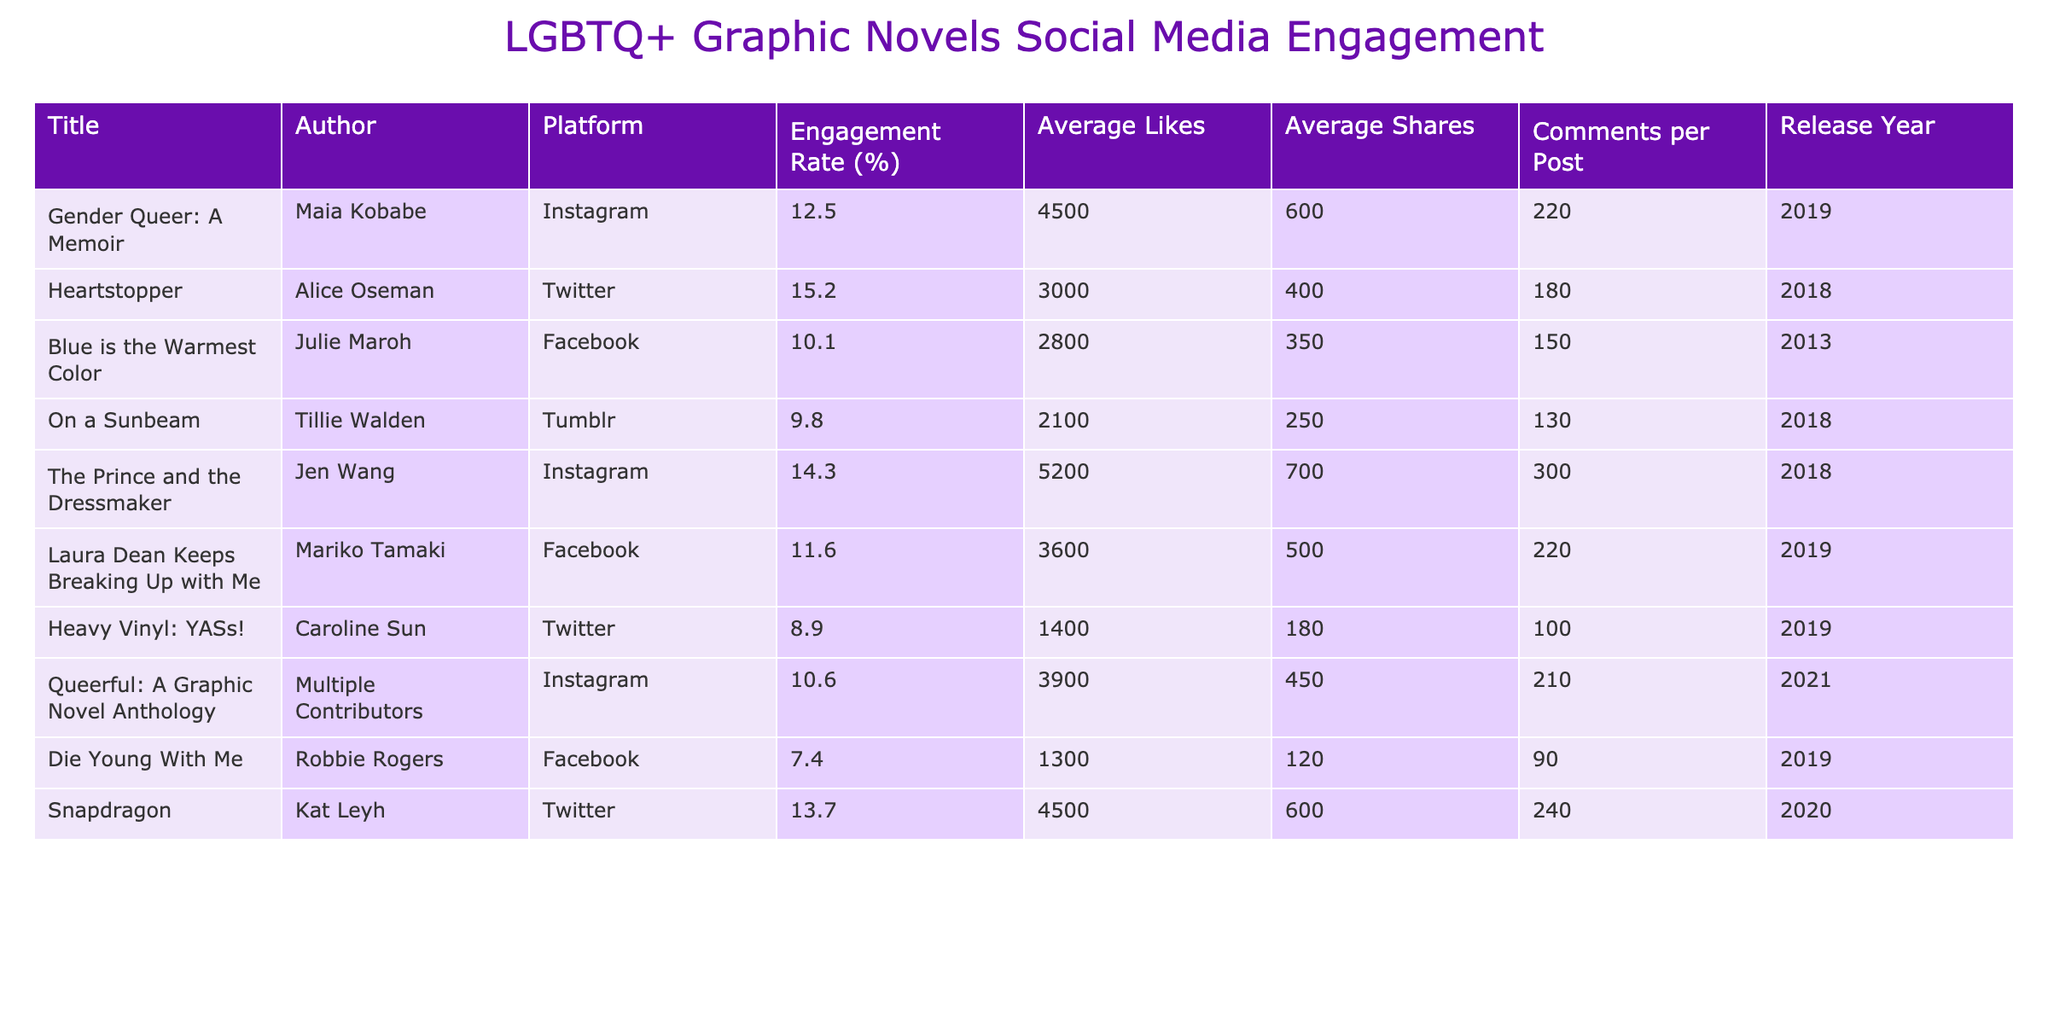What is the engagement rate for "Heartstopper"? The engagement rate for "Heartstopper" is listed directly under the Engagement Rate (%) column next to the title. The value there is 15.2%
Answer: 15.2% Which graphic novel has the highest average shares? To find the highest average shares, I compare the values in the Average Shares column. The maximum value is 700, which belongs to "The Prince and the Dressmaker."
Answer: The Prince and the Dressmaker Is "Heavy Vinyl: YASs!" released after 2020? This novel was released in 2019, as indicated in the Release Year column. Therefore, it is not released after 2020.
Answer: No What is the average engagement rate of the graphic novels listed? To calculate the average engagement rate, sum all the engagement rates (12.5 + 15.2 + 10.1 + 9.8 + 14.3 + 11.6 + 8.9 + 10.6 + 7.4 + 13.7 = 99.1) and divide by the number of graphic novels (10). The calculation yields an average of 9.91.
Answer: 9.91 Which platform had the lowest average likes? I compare the Average Likes across each graphic novel. The lowest average likes are found with "Die Young With Me" at 1300.
Answer: Die Young With Me Did any graphic novel released in 2018 have an engagement rate higher than 14%? Looking at the 2018 releases ("Heartstopper", "On a Sunbeam", and "The Prince and the Dressmaker"), I see that "Heartstopper" has 15.2% and "The Prince and the Dressmaker" has 14.3%, both of which are higher than 14%.
Answer: Yes Which author had the most engagement on Instagram? The Authors and their corresponding engagement rates on Instagram are checked from the table. "The Prince and the Dressmaker" by Jen Wang has the highest engagement rate on this platform at 14.3%.
Answer: Jen Wang What is the total number of comments across all posts for "Laura Dean Keeps Breaking Up with Me"? There are 220 comments per post for "Laura Dean Keeps Breaking Up with Me," and since it represents the data for one graphic novel only, this is the total.
Answer: 220 